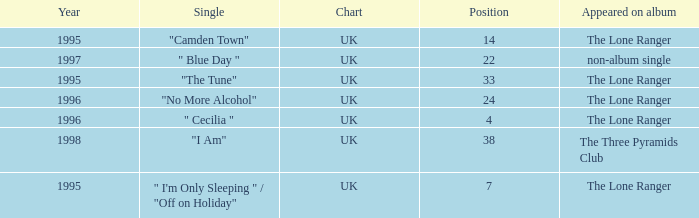After 1996, what is the average position? 30.0. 